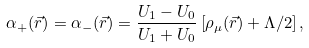<formula> <loc_0><loc_0><loc_500><loc_500>\alpha _ { + } ( \vec { r } ) = \alpha _ { - } ( \vec { r } ) = \frac { U _ { 1 } - U _ { 0 } } { U _ { 1 } + U _ { 0 } } \left [ \rho _ { \mu } ( \vec { r } ) + \Lambda / 2 \right ] ,</formula> 